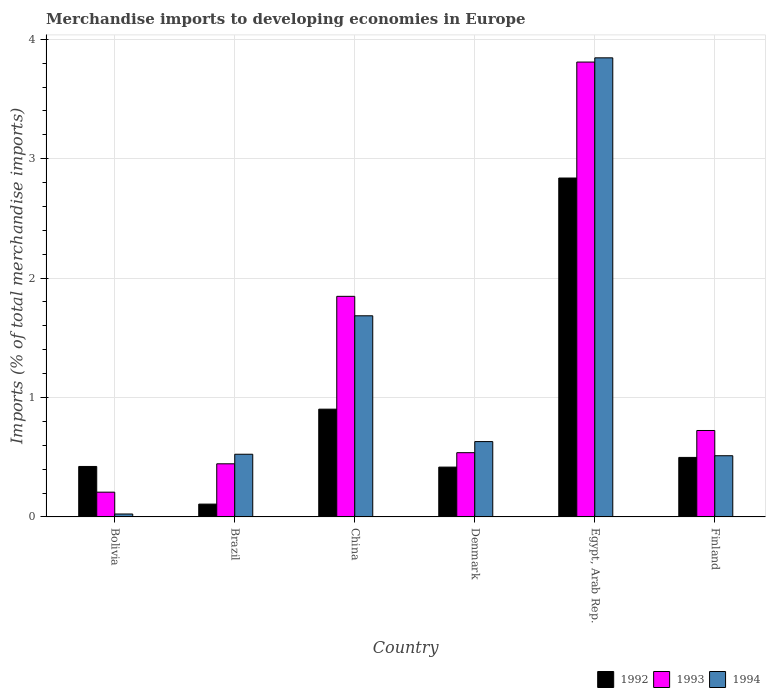How many different coloured bars are there?
Keep it short and to the point. 3. How many groups of bars are there?
Your response must be concise. 6. Are the number of bars on each tick of the X-axis equal?
Make the answer very short. Yes. How many bars are there on the 4th tick from the left?
Offer a very short reply. 3. What is the percentage total merchandise imports in 1993 in Bolivia?
Your response must be concise. 0.21. Across all countries, what is the maximum percentage total merchandise imports in 1992?
Your answer should be compact. 2.84. Across all countries, what is the minimum percentage total merchandise imports in 1993?
Your answer should be compact. 0.21. In which country was the percentage total merchandise imports in 1994 maximum?
Provide a succinct answer. Egypt, Arab Rep. In which country was the percentage total merchandise imports in 1992 minimum?
Offer a terse response. Brazil. What is the total percentage total merchandise imports in 1994 in the graph?
Your answer should be very brief. 7.22. What is the difference between the percentage total merchandise imports in 1993 in China and that in Finland?
Your answer should be compact. 1.12. What is the difference between the percentage total merchandise imports in 1994 in Brazil and the percentage total merchandise imports in 1993 in China?
Your answer should be compact. -1.32. What is the average percentage total merchandise imports in 1993 per country?
Make the answer very short. 1.26. What is the difference between the percentage total merchandise imports of/in 1994 and percentage total merchandise imports of/in 1993 in China?
Offer a terse response. -0.16. In how many countries, is the percentage total merchandise imports in 1992 greater than 0.4 %?
Keep it short and to the point. 5. What is the ratio of the percentage total merchandise imports in 1992 in Denmark to that in Egypt, Arab Rep.?
Provide a succinct answer. 0.15. Is the percentage total merchandise imports in 1992 in Denmark less than that in Finland?
Make the answer very short. Yes. Is the difference between the percentage total merchandise imports in 1994 in Bolivia and China greater than the difference between the percentage total merchandise imports in 1993 in Bolivia and China?
Ensure brevity in your answer.  No. What is the difference between the highest and the second highest percentage total merchandise imports in 1994?
Your answer should be very brief. -1.05. What is the difference between the highest and the lowest percentage total merchandise imports in 1992?
Your answer should be compact. 2.73. What does the 3rd bar from the left in China represents?
Your answer should be compact. 1994. What is the difference between two consecutive major ticks on the Y-axis?
Provide a succinct answer. 1. Where does the legend appear in the graph?
Your answer should be very brief. Bottom right. What is the title of the graph?
Make the answer very short. Merchandise imports to developing economies in Europe. Does "1987" appear as one of the legend labels in the graph?
Provide a succinct answer. No. What is the label or title of the X-axis?
Your answer should be compact. Country. What is the label or title of the Y-axis?
Your answer should be very brief. Imports (% of total merchandise imports). What is the Imports (% of total merchandise imports) of 1992 in Bolivia?
Keep it short and to the point. 0.42. What is the Imports (% of total merchandise imports) of 1993 in Bolivia?
Your answer should be very brief. 0.21. What is the Imports (% of total merchandise imports) in 1994 in Bolivia?
Keep it short and to the point. 0.02. What is the Imports (% of total merchandise imports) of 1992 in Brazil?
Provide a short and direct response. 0.11. What is the Imports (% of total merchandise imports) of 1993 in Brazil?
Offer a terse response. 0.44. What is the Imports (% of total merchandise imports) in 1994 in Brazil?
Offer a terse response. 0.52. What is the Imports (% of total merchandise imports) of 1992 in China?
Offer a terse response. 0.9. What is the Imports (% of total merchandise imports) in 1993 in China?
Your response must be concise. 1.85. What is the Imports (% of total merchandise imports) in 1994 in China?
Offer a terse response. 1.68. What is the Imports (% of total merchandise imports) in 1992 in Denmark?
Keep it short and to the point. 0.42. What is the Imports (% of total merchandise imports) in 1993 in Denmark?
Keep it short and to the point. 0.54. What is the Imports (% of total merchandise imports) in 1994 in Denmark?
Keep it short and to the point. 0.63. What is the Imports (% of total merchandise imports) in 1992 in Egypt, Arab Rep.?
Your response must be concise. 2.84. What is the Imports (% of total merchandise imports) of 1993 in Egypt, Arab Rep.?
Your answer should be compact. 3.81. What is the Imports (% of total merchandise imports) of 1994 in Egypt, Arab Rep.?
Your answer should be compact. 3.84. What is the Imports (% of total merchandise imports) of 1992 in Finland?
Provide a short and direct response. 0.5. What is the Imports (% of total merchandise imports) in 1993 in Finland?
Your answer should be compact. 0.72. What is the Imports (% of total merchandise imports) in 1994 in Finland?
Your response must be concise. 0.51. Across all countries, what is the maximum Imports (% of total merchandise imports) in 1992?
Your response must be concise. 2.84. Across all countries, what is the maximum Imports (% of total merchandise imports) of 1993?
Offer a terse response. 3.81. Across all countries, what is the maximum Imports (% of total merchandise imports) of 1994?
Offer a very short reply. 3.84. Across all countries, what is the minimum Imports (% of total merchandise imports) of 1992?
Your answer should be very brief. 0.11. Across all countries, what is the minimum Imports (% of total merchandise imports) of 1993?
Your answer should be compact. 0.21. Across all countries, what is the minimum Imports (% of total merchandise imports) of 1994?
Your response must be concise. 0.02. What is the total Imports (% of total merchandise imports) of 1992 in the graph?
Provide a succinct answer. 5.19. What is the total Imports (% of total merchandise imports) in 1993 in the graph?
Provide a short and direct response. 7.57. What is the total Imports (% of total merchandise imports) of 1994 in the graph?
Provide a succinct answer. 7.22. What is the difference between the Imports (% of total merchandise imports) of 1992 in Bolivia and that in Brazil?
Provide a succinct answer. 0.32. What is the difference between the Imports (% of total merchandise imports) in 1993 in Bolivia and that in Brazil?
Provide a succinct answer. -0.24. What is the difference between the Imports (% of total merchandise imports) of 1994 in Bolivia and that in Brazil?
Give a very brief answer. -0.5. What is the difference between the Imports (% of total merchandise imports) in 1992 in Bolivia and that in China?
Your answer should be very brief. -0.48. What is the difference between the Imports (% of total merchandise imports) of 1993 in Bolivia and that in China?
Provide a short and direct response. -1.64. What is the difference between the Imports (% of total merchandise imports) of 1994 in Bolivia and that in China?
Offer a terse response. -1.66. What is the difference between the Imports (% of total merchandise imports) of 1992 in Bolivia and that in Denmark?
Your response must be concise. 0.01. What is the difference between the Imports (% of total merchandise imports) in 1993 in Bolivia and that in Denmark?
Ensure brevity in your answer.  -0.33. What is the difference between the Imports (% of total merchandise imports) in 1994 in Bolivia and that in Denmark?
Ensure brevity in your answer.  -0.61. What is the difference between the Imports (% of total merchandise imports) in 1992 in Bolivia and that in Egypt, Arab Rep.?
Your response must be concise. -2.42. What is the difference between the Imports (% of total merchandise imports) in 1993 in Bolivia and that in Egypt, Arab Rep.?
Give a very brief answer. -3.6. What is the difference between the Imports (% of total merchandise imports) in 1994 in Bolivia and that in Egypt, Arab Rep.?
Your answer should be very brief. -3.82. What is the difference between the Imports (% of total merchandise imports) of 1992 in Bolivia and that in Finland?
Your answer should be very brief. -0.08. What is the difference between the Imports (% of total merchandise imports) in 1993 in Bolivia and that in Finland?
Give a very brief answer. -0.52. What is the difference between the Imports (% of total merchandise imports) of 1994 in Bolivia and that in Finland?
Your response must be concise. -0.49. What is the difference between the Imports (% of total merchandise imports) in 1992 in Brazil and that in China?
Your answer should be compact. -0.8. What is the difference between the Imports (% of total merchandise imports) of 1993 in Brazil and that in China?
Provide a short and direct response. -1.4. What is the difference between the Imports (% of total merchandise imports) of 1994 in Brazil and that in China?
Your answer should be very brief. -1.16. What is the difference between the Imports (% of total merchandise imports) in 1992 in Brazil and that in Denmark?
Your answer should be very brief. -0.31. What is the difference between the Imports (% of total merchandise imports) of 1993 in Brazil and that in Denmark?
Offer a terse response. -0.09. What is the difference between the Imports (% of total merchandise imports) in 1994 in Brazil and that in Denmark?
Your response must be concise. -0.11. What is the difference between the Imports (% of total merchandise imports) of 1992 in Brazil and that in Egypt, Arab Rep.?
Your response must be concise. -2.73. What is the difference between the Imports (% of total merchandise imports) of 1993 in Brazil and that in Egypt, Arab Rep.?
Keep it short and to the point. -3.36. What is the difference between the Imports (% of total merchandise imports) in 1994 in Brazil and that in Egypt, Arab Rep.?
Give a very brief answer. -3.32. What is the difference between the Imports (% of total merchandise imports) of 1992 in Brazil and that in Finland?
Give a very brief answer. -0.39. What is the difference between the Imports (% of total merchandise imports) in 1993 in Brazil and that in Finland?
Provide a short and direct response. -0.28. What is the difference between the Imports (% of total merchandise imports) of 1994 in Brazil and that in Finland?
Provide a short and direct response. 0.01. What is the difference between the Imports (% of total merchandise imports) of 1992 in China and that in Denmark?
Provide a short and direct response. 0.49. What is the difference between the Imports (% of total merchandise imports) in 1993 in China and that in Denmark?
Your response must be concise. 1.31. What is the difference between the Imports (% of total merchandise imports) in 1994 in China and that in Denmark?
Offer a very short reply. 1.05. What is the difference between the Imports (% of total merchandise imports) of 1992 in China and that in Egypt, Arab Rep.?
Make the answer very short. -1.94. What is the difference between the Imports (% of total merchandise imports) in 1993 in China and that in Egypt, Arab Rep.?
Make the answer very short. -1.96. What is the difference between the Imports (% of total merchandise imports) in 1994 in China and that in Egypt, Arab Rep.?
Provide a succinct answer. -2.16. What is the difference between the Imports (% of total merchandise imports) in 1992 in China and that in Finland?
Provide a succinct answer. 0.4. What is the difference between the Imports (% of total merchandise imports) in 1993 in China and that in Finland?
Offer a very short reply. 1.12. What is the difference between the Imports (% of total merchandise imports) in 1994 in China and that in Finland?
Make the answer very short. 1.17. What is the difference between the Imports (% of total merchandise imports) of 1992 in Denmark and that in Egypt, Arab Rep.?
Provide a succinct answer. -2.42. What is the difference between the Imports (% of total merchandise imports) of 1993 in Denmark and that in Egypt, Arab Rep.?
Offer a very short reply. -3.27. What is the difference between the Imports (% of total merchandise imports) of 1994 in Denmark and that in Egypt, Arab Rep.?
Your answer should be compact. -3.21. What is the difference between the Imports (% of total merchandise imports) in 1992 in Denmark and that in Finland?
Your answer should be compact. -0.08. What is the difference between the Imports (% of total merchandise imports) of 1993 in Denmark and that in Finland?
Keep it short and to the point. -0.19. What is the difference between the Imports (% of total merchandise imports) of 1994 in Denmark and that in Finland?
Offer a terse response. 0.12. What is the difference between the Imports (% of total merchandise imports) of 1992 in Egypt, Arab Rep. and that in Finland?
Offer a terse response. 2.34. What is the difference between the Imports (% of total merchandise imports) of 1993 in Egypt, Arab Rep. and that in Finland?
Your answer should be very brief. 3.09. What is the difference between the Imports (% of total merchandise imports) in 1994 in Egypt, Arab Rep. and that in Finland?
Offer a terse response. 3.33. What is the difference between the Imports (% of total merchandise imports) in 1992 in Bolivia and the Imports (% of total merchandise imports) in 1993 in Brazil?
Offer a very short reply. -0.02. What is the difference between the Imports (% of total merchandise imports) of 1992 in Bolivia and the Imports (% of total merchandise imports) of 1994 in Brazil?
Offer a terse response. -0.1. What is the difference between the Imports (% of total merchandise imports) in 1993 in Bolivia and the Imports (% of total merchandise imports) in 1994 in Brazil?
Provide a short and direct response. -0.32. What is the difference between the Imports (% of total merchandise imports) of 1992 in Bolivia and the Imports (% of total merchandise imports) of 1993 in China?
Make the answer very short. -1.42. What is the difference between the Imports (% of total merchandise imports) in 1992 in Bolivia and the Imports (% of total merchandise imports) in 1994 in China?
Give a very brief answer. -1.26. What is the difference between the Imports (% of total merchandise imports) in 1993 in Bolivia and the Imports (% of total merchandise imports) in 1994 in China?
Your answer should be very brief. -1.48. What is the difference between the Imports (% of total merchandise imports) of 1992 in Bolivia and the Imports (% of total merchandise imports) of 1993 in Denmark?
Offer a terse response. -0.12. What is the difference between the Imports (% of total merchandise imports) in 1992 in Bolivia and the Imports (% of total merchandise imports) in 1994 in Denmark?
Offer a terse response. -0.21. What is the difference between the Imports (% of total merchandise imports) in 1993 in Bolivia and the Imports (% of total merchandise imports) in 1994 in Denmark?
Offer a terse response. -0.42. What is the difference between the Imports (% of total merchandise imports) in 1992 in Bolivia and the Imports (% of total merchandise imports) in 1993 in Egypt, Arab Rep.?
Your answer should be very brief. -3.39. What is the difference between the Imports (% of total merchandise imports) of 1992 in Bolivia and the Imports (% of total merchandise imports) of 1994 in Egypt, Arab Rep.?
Ensure brevity in your answer.  -3.42. What is the difference between the Imports (% of total merchandise imports) of 1993 in Bolivia and the Imports (% of total merchandise imports) of 1994 in Egypt, Arab Rep.?
Offer a very short reply. -3.64. What is the difference between the Imports (% of total merchandise imports) of 1992 in Bolivia and the Imports (% of total merchandise imports) of 1993 in Finland?
Make the answer very short. -0.3. What is the difference between the Imports (% of total merchandise imports) in 1992 in Bolivia and the Imports (% of total merchandise imports) in 1994 in Finland?
Offer a very short reply. -0.09. What is the difference between the Imports (% of total merchandise imports) in 1993 in Bolivia and the Imports (% of total merchandise imports) in 1994 in Finland?
Your answer should be compact. -0.31. What is the difference between the Imports (% of total merchandise imports) of 1992 in Brazil and the Imports (% of total merchandise imports) of 1993 in China?
Give a very brief answer. -1.74. What is the difference between the Imports (% of total merchandise imports) of 1992 in Brazil and the Imports (% of total merchandise imports) of 1994 in China?
Offer a very short reply. -1.58. What is the difference between the Imports (% of total merchandise imports) in 1993 in Brazil and the Imports (% of total merchandise imports) in 1994 in China?
Your response must be concise. -1.24. What is the difference between the Imports (% of total merchandise imports) of 1992 in Brazil and the Imports (% of total merchandise imports) of 1993 in Denmark?
Provide a succinct answer. -0.43. What is the difference between the Imports (% of total merchandise imports) in 1992 in Brazil and the Imports (% of total merchandise imports) in 1994 in Denmark?
Ensure brevity in your answer.  -0.52. What is the difference between the Imports (% of total merchandise imports) in 1993 in Brazil and the Imports (% of total merchandise imports) in 1994 in Denmark?
Your answer should be very brief. -0.19. What is the difference between the Imports (% of total merchandise imports) in 1992 in Brazil and the Imports (% of total merchandise imports) in 1993 in Egypt, Arab Rep.?
Ensure brevity in your answer.  -3.7. What is the difference between the Imports (% of total merchandise imports) in 1992 in Brazil and the Imports (% of total merchandise imports) in 1994 in Egypt, Arab Rep.?
Offer a very short reply. -3.74. What is the difference between the Imports (% of total merchandise imports) of 1993 in Brazil and the Imports (% of total merchandise imports) of 1994 in Egypt, Arab Rep.?
Give a very brief answer. -3.4. What is the difference between the Imports (% of total merchandise imports) of 1992 in Brazil and the Imports (% of total merchandise imports) of 1993 in Finland?
Provide a succinct answer. -0.62. What is the difference between the Imports (% of total merchandise imports) in 1992 in Brazil and the Imports (% of total merchandise imports) in 1994 in Finland?
Keep it short and to the point. -0.41. What is the difference between the Imports (% of total merchandise imports) of 1993 in Brazil and the Imports (% of total merchandise imports) of 1994 in Finland?
Your response must be concise. -0.07. What is the difference between the Imports (% of total merchandise imports) in 1992 in China and the Imports (% of total merchandise imports) in 1993 in Denmark?
Keep it short and to the point. 0.36. What is the difference between the Imports (% of total merchandise imports) in 1992 in China and the Imports (% of total merchandise imports) in 1994 in Denmark?
Keep it short and to the point. 0.27. What is the difference between the Imports (% of total merchandise imports) in 1993 in China and the Imports (% of total merchandise imports) in 1994 in Denmark?
Make the answer very short. 1.22. What is the difference between the Imports (% of total merchandise imports) of 1992 in China and the Imports (% of total merchandise imports) of 1993 in Egypt, Arab Rep.?
Keep it short and to the point. -2.91. What is the difference between the Imports (% of total merchandise imports) in 1992 in China and the Imports (% of total merchandise imports) in 1994 in Egypt, Arab Rep.?
Keep it short and to the point. -2.94. What is the difference between the Imports (% of total merchandise imports) in 1993 in China and the Imports (% of total merchandise imports) in 1994 in Egypt, Arab Rep.?
Provide a succinct answer. -2. What is the difference between the Imports (% of total merchandise imports) of 1992 in China and the Imports (% of total merchandise imports) of 1993 in Finland?
Keep it short and to the point. 0.18. What is the difference between the Imports (% of total merchandise imports) of 1992 in China and the Imports (% of total merchandise imports) of 1994 in Finland?
Your answer should be very brief. 0.39. What is the difference between the Imports (% of total merchandise imports) of 1993 in China and the Imports (% of total merchandise imports) of 1994 in Finland?
Offer a terse response. 1.33. What is the difference between the Imports (% of total merchandise imports) of 1992 in Denmark and the Imports (% of total merchandise imports) of 1993 in Egypt, Arab Rep.?
Your answer should be compact. -3.39. What is the difference between the Imports (% of total merchandise imports) in 1992 in Denmark and the Imports (% of total merchandise imports) in 1994 in Egypt, Arab Rep.?
Give a very brief answer. -3.43. What is the difference between the Imports (% of total merchandise imports) of 1993 in Denmark and the Imports (% of total merchandise imports) of 1994 in Egypt, Arab Rep.?
Provide a short and direct response. -3.31. What is the difference between the Imports (% of total merchandise imports) in 1992 in Denmark and the Imports (% of total merchandise imports) in 1993 in Finland?
Ensure brevity in your answer.  -0.31. What is the difference between the Imports (% of total merchandise imports) of 1992 in Denmark and the Imports (% of total merchandise imports) of 1994 in Finland?
Your response must be concise. -0.1. What is the difference between the Imports (% of total merchandise imports) in 1993 in Denmark and the Imports (% of total merchandise imports) in 1994 in Finland?
Ensure brevity in your answer.  0.03. What is the difference between the Imports (% of total merchandise imports) of 1992 in Egypt, Arab Rep. and the Imports (% of total merchandise imports) of 1993 in Finland?
Your response must be concise. 2.11. What is the difference between the Imports (% of total merchandise imports) of 1992 in Egypt, Arab Rep. and the Imports (% of total merchandise imports) of 1994 in Finland?
Keep it short and to the point. 2.33. What is the difference between the Imports (% of total merchandise imports) of 1993 in Egypt, Arab Rep. and the Imports (% of total merchandise imports) of 1994 in Finland?
Your answer should be very brief. 3.3. What is the average Imports (% of total merchandise imports) in 1992 per country?
Provide a succinct answer. 0.86. What is the average Imports (% of total merchandise imports) in 1993 per country?
Keep it short and to the point. 1.26. What is the average Imports (% of total merchandise imports) in 1994 per country?
Give a very brief answer. 1.2. What is the difference between the Imports (% of total merchandise imports) in 1992 and Imports (% of total merchandise imports) in 1993 in Bolivia?
Offer a very short reply. 0.22. What is the difference between the Imports (% of total merchandise imports) of 1992 and Imports (% of total merchandise imports) of 1994 in Bolivia?
Your answer should be compact. 0.4. What is the difference between the Imports (% of total merchandise imports) in 1993 and Imports (% of total merchandise imports) in 1994 in Bolivia?
Provide a short and direct response. 0.18. What is the difference between the Imports (% of total merchandise imports) in 1992 and Imports (% of total merchandise imports) in 1993 in Brazil?
Your answer should be very brief. -0.34. What is the difference between the Imports (% of total merchandise imports) in 1992 and Imports (% of total merchandise imports) in 1994 in Brazil?
Give a very brief answer. -0.42. What is the difference between the Imports (% of total merchandise imports) in 1993 and Imports (% of total merchandise imports) in 1994 in Brazil?
Offer a terse response. -0.08. What is the difference between the Imports (% of total merchandise imports) in 1992 and Imports (% of total merchandise imports) in 1993 in China?
Give a very brief answer. -0.94. What is the difference between the Imports (% of total merchandise imports) of 1992 and Imports (% of total merchandise imports) of 1994 in China?
Provide a short and direct response. -0.78. What is the difference between the Imports (% of total merchandise imports) in 1993 and Imports (% of total merchandise imports) in 1994 in China?
Offer a terse response. 0.16. What is the difference between the Imports (% of total merchandise imports) in 1992 and Imports (% of total merchandise imports) in 1993 in Denmark?
Your response must be concise. -0.12. What is the difference between the Imports (% of total merchandise imports) of 1992 and Imports (% of total merchandise imports) of 1994 in Denmark?
Your response must be concise. -0.21. What is the difference between the Imports (% of total merchandise imports) in 1993 and Imports (% of total merchandise imports) in 1994 in Denmark?
Ensure brevity in your answer.  -0.09. What is the difference between the Imports (% of total merchandise imports) of 1992 and Imports (% of total merchandise imports) of 1993 in Egypt, Arab Rep.?
Offer a terse response. -0.97. What is the difference between the Imports (% of total merchandise imports) of 1992 and Imports (% of total merchandise imports) of 1994 in Egypt, Arab Rep.?
Provide a short and direct response. -1.01. What is the difference between the Imports (% of total merchandise imports) of 1993 and Imports (% of total merchandise imports) of 1994 in Egypt, Arab Rep.?
Give a very brief answer. -0.04. What is the difference between the Imports (% of total merchandise imports) of 1992 and Imports (% of total merchandise imports) of 1993 in Finland?
Make the answer very short. -0.23. What is the difference between the Imports (% of total merchandise imports) of 1992 and Imports (% of total merchandise imports) of 1994 in Finland?
Your answer should be very brief. -0.01. What is the difference between the Imports (% of total merchandise imports) of 1993 and Imports (% of total merchandise imports) of 1994 in Finland?
Make the answer very short. 0.21. What is the ratio of the Imports (% of total merchandise imports) in 1992 in Bolivia to that in Brazil?
Offer a very short reply. 3.94. What is the ratio of the Imports (% of total merchandise imports) of 1993 in Bolivia to that in Brazil?
Your answer should be very brief. 0.47. What is the ratio of the Imports (% of total merchandise imports) in 1994 in Bolivia to that in Brazil?
Your answer should be very brief. 0.05. What is the ratio of the Imports (% of total merchandise imports) in 1992 in Bolivia to that in China?
Provide a succinct answer. 0.47. What is the ratio of the Imports (% of total merchandise imports) of 1993 in Bolivia to that in China?
Your response must be concise. 0.11. What is the ratio of the Imports (% of total merchandise imports) in 1994 in Bolivia to that in China?
Your answer should be compact. 0.01. What is the ratio of the Imports (% of total merchandise imports) of 1992 in Bolivia to that in Denmark?
Offer a very short reply. 1.01. What is the ratio of the Imports (% of total merchandise imports) in 1993 in Bolivia to that in Denmark?
Your response must be concise. 0.39. What is the ratio of the Imports (% of total merchandise imports) of 1994 in Bolivia to that in Denmark?
Your answer should be very brief. 0.04. What is the ratio of the Imports (% of total merchandise imports) in 1992 in Bolivia to that in Egypt, Arab Rep.?
Ensure brevity in your answer.  0.15. What is the ratio of the Imports (% of total merchandise imports) of 1993 in Bolivia to that in Egypt, Arab Rep.?
Ensure brevity in your answer.  0.05. What is the ratio of the Imports (% of total merchandise imports) in 1994 in Bolivia to that in Egypt, Arab Rep.?
Keep it short and to the point. 0.01. What is the ratio of the Imports (% of total merchandise imports) in 1992 in Bolivia to that in Finland?
Make the answer very short. 0.85. What is the ratio of the Imports (% of total merchandise imports) of 1993 in Bolivia to that in Finland?
Your answer should be very brief. 0.29. What is the ratio of the Imports (% of total merchandise imports) of 1994 in Bolivia to that in Finland?
Offer a very short reply. 0.05. What is the ratio of the Imports (% of total merchandise imports) of 1992 in Brazil to that in China?
Ensure brevity in your answer.  0.12. What is the ratio of the Imports (% of total merchandise imports) in 1993 in Brazil to that in China?
Offer a very short reply. 0.24. What is the ratio of the Imports (% of total merchandise imports) in 1994 in Brazil to that in China?
Your answer should be very brief. 0.31. What is the ratio of the Imports (% of total merchandise imports) of 1992 in Brazil to that in Denmark?
Your answer should be compact. 0.26. What is the ratio of the Imports (% of total merchandise imports) in 1993 in Brazil to that in Denmark?
Offer a very short reply. 0.83. What is the ratio of the Imports (% of total merchandise imports) of 1994 in Brazil to that in Denmark?
Your answer should be very brief. 0.83. What is the ratio of the Imports (% of total merchandise imports) of 1992 in Brazil to that in Egypt, Arab Rep.?
Give a very brief answer. 0.04. What is the ratio of the Imports (% of total merchandise imports) in 1993 in Brazil to that in Egypt, Arab Rep.?
Offer a very short reply. 0.12. What is the ratio of the Imports (% of total merchandise imports) in 1994 in Brazil to that in Egypt, Arab Rep.?
Provide a short and direct response. 0.14. What is the ratio of the Imports (% of total merchandise imports) in 1992 in Brazil to that in Finland?
Your answer should be very brief. 0.22. What is the ratio of the Imports (% of total merchandise imports) in 1993 in Brazil to that in Finland?
Offer a very short reply. 0.61. What is the ratio of the Imports (% of total merchandise imports) of 1994 in Brazil to that in Finland?
Provide a succinct answer. 1.02. What is the ratio of the Imports (% of total merchandise imports) in 1992 in China to that in Denmark?
Offer a very short reply. 2.16. What is the ratio of the Imports (% of total merchandise imports) in 1993 in China to that in Denmark?
Make the answer very short. 3.43. What is the ratio of the Imports (% of total merchandise imports) in 1994 in China to that in Denmark?
Give a very brief answer. 2.67. What is the ratio of the Imports (% of total merchandise imports) of 1992 in China to that in Egypt, Arab Rep.?
Make the answer very short. 0.32. What is the ratio of the Imports (% of total merchandise imports) of 1993 in China to that in Egypt, Arab Rep.?
Make the answer very short. 0.48. What is the ratio of the Imports (% of total merchandise imports) of 1994 in China to that in Egypt, Arab Rep.?
Provide a short and direct response. 0.44. What is the ratio of the Imports (% of total merchandise imports) in 1992 in China to that in Finland?
Your response must be concise. 1.81. What is the ratio of the Imports (% of total merchandise imports) in 1993 in China to that in Finland?
Ensure brevity in your answer.  2.55. What is the ratio of the Imports (% of total merchandise imports) in 1994 in China to that in Finland?
Provide a short and direct response. 3.29. What is the ratio of the Imports (% of total merchandise imports) in 1992 in Denmark to that in Egypt, Arab Rep.?
Provide a succinct answer. 0.15. What is the ratio of the Imports (% of total merchandise imports) in 1993 in Denmark to that in Egypt, Arab Rep.?
Make the answer very short. 0.14. What is the ratio of the Imports (% of total merchandise imports) in 1994 in Denmark to that in Egypt, Arab Rep.?
Make the answer very short. 0.16. What is the ratio of the Imports (% of total merchandise imports) of 1992 in Denmark to that in Finland?
Your response must be concise. 0.84. What is the ratio of the Imports (% of total merchandise imports) in 1993 in Denmark to that in Finland?
Offer a very short reply. 0.74. What is the ratio of the Imports (% of total merchandise imports) in 1994 in Denmark to that in Finland?
Keep it short and to the point. 1.23. What is the ratio of the Imports (% of total merchandise imports) of 1992 in Egypt, Arab Rep. to that in Finland?
Make the answer very short. 5.69. What is the ratio of the Imports (% of total merchandise imports) of 1993 in Egypt, Arab Rep. to that in Finland?
Keep it short and to the point. 5.26. What is the ratio of the Imports (% of total merchandise imports) of 1994 in Egypt, Arab Rep. to that in Finland?
Your answer should be compact. 7.5. What is the difference between the highest and the second highest Imports (% of total merchandise imports) of 1992?
Make the answer very short. 1.94. What is the difference between the highest and the second highest Imports (% of total merchandise imports) in 1993?
Ensure brevity in your answer.  1.96. What is the difference between the highest and the second highest Imports (% of total merchandise imports) in 1994?
Your answer should be compact. 2.16. What is the difference between the highest and the lowest Imports (% of total merchandise imports) of 1992?
Your answer should be compact. 2.73. What is the difference between the highest and the lowest Imports (% of total merchandise imports) of 1993?
Your response must be concise. 3.6. What is the difference between the highest and the lowest Imports (% of total merchandise imports) of 1994?
Offer a very short reply. 3.82. 